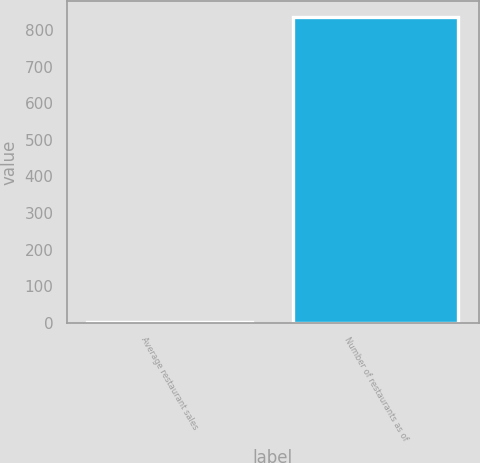Convert chart. <chart><loc_0><loc_0><loc_500><loc_500><bar_chart><fcel>Average restaurant sales<fcel>Number of restaurants as of<nl><fcel>1.76<fcel>837<nl></chart> 